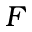Convert formula to latex. <formula><loc_0><loc_0><loc_500><loc_500>F</formula> 